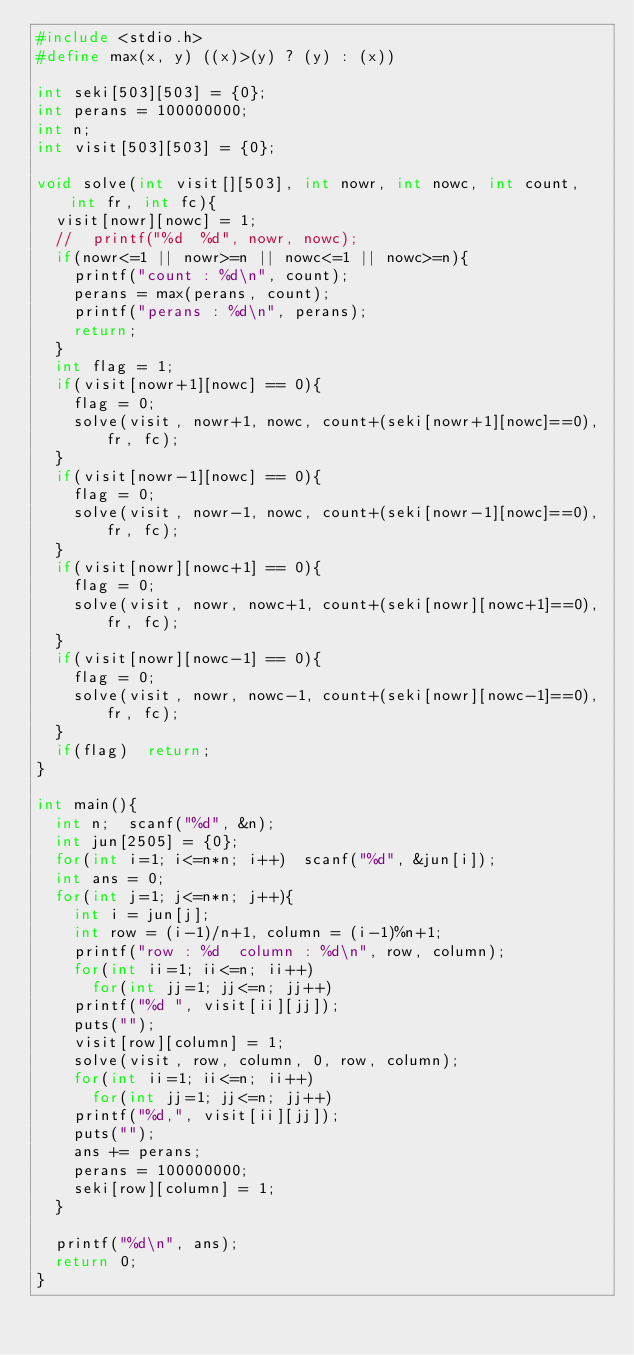Convert code to text. <code><loc_0><loc_0><loc_500><loc_500><_C_>#include <stdio.h>
#define max(x, y) ((x)>(y) ? (y) : (x))

int seki[503][503] = {0};
int perans = 100000000;
int n;
int visit[503][503] = {0};

void solve(int visit[][503], int nowr, int nowc, int count, int fr, int fc){
  visit[nowr][nowc] = 1;
  //  printf("%d  %d", nowr, nowc);
  if(nowr<=1 || nowr>=n || nowc<=1 || nowc>=n){
    printf("count : %d\n", count);
    perans = max(perans, count);
    printf("perans : %d\n", perans);
    return;
  }
  int flag = 1;
  if(visit[nowr+1][nowc] == 0){
    flag = 0;
    solve(visit, nowr+1, nowc, count+(seki[nowr+1][nowc]==0), fr, fc);
  }
  if(visit[nowr-1][nowc] == 0){
    flag = 0;
    solve(visit, nowr-1, nowc, count+(seki[nowr-1][nowc]==0), fr, fc);
  }
  if(visit[nowr][nowc+1] == 0){
    flag = 0;
    solve(visit, nowr, nowc+1, count+(seki[nowr][nowc+1]==0), fr, fc);
  }
  if(visit[nowr][nowc-1] == 0){
    flag = 0;
    solve(visit, nowr, nowc-1, count+(seki[nowr][nowc-1]==0), fr, fc);
  }
  if(flag)  return;
}

int main(){
  int n;  scanf("%d", &n);
  int jun[2505] = {0};
  for(int i=1; i<=n*n; i++)  scanf("%d", &jun[i]);
  int ans = 0;
  for(int j=1; j<=n*n; j++){
    int i = jun[j];
    int row = (i-1)/n+1, column = (i-1)%n+1;
    printf("row : %d  column : %d\n", row, column);
    for(int ii=1; ii<=n; ii++)
      for(int jj=1; jj<=n; jj++)
	printf("%d ", visit[ii][jj]);
    puts("");
    visit[row][column] = 1;
    solve(visit, row, column, 0, row, column);
    for(int ii=1; ii<=n; ii++)
      for(int jj=1; jj<=n; jj++)
	printf("%d,", visit[ii][jj]);
    puts("");
    ans += perans;
    perans = 100000000;
    seki[row][column] = 1;
  }

  printf("%d\n", ans);
  return 0;
}
</code> 